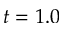<formula> <loc_0><loc_0><loc_500><loc_500>t = 1 . 0</formula> 